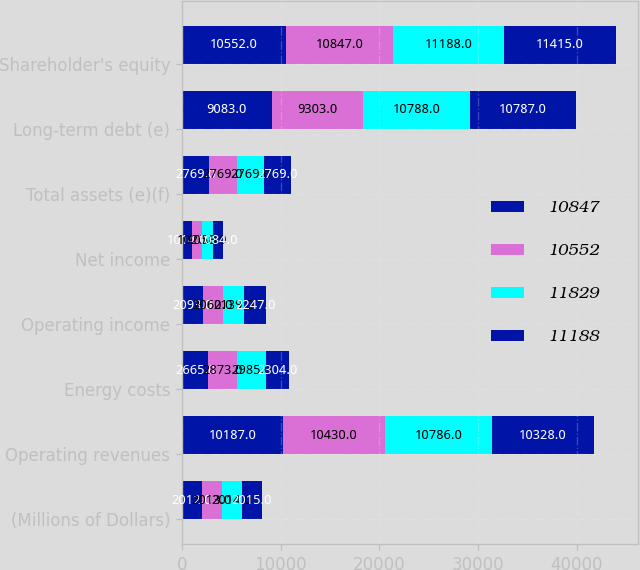<chart> <loc_0><loc_0><loc_500><loc_500><stacked_bar_chart><ecel><fcel>(Millions of Dollars)<fcel>Operating revenues<fcel>Energy costs<fcel>Operating income<fcel>Net income<fcel>Total assets (e)(f)<fcel>Long-term debt (e)<fcel>Shareholder's equity<nl><fcel>10847<fcel>2012<fcel>10187<fcel>2665<fcel>2093<fcel>1014<fcel>2769<fcel>9083<fcel>10552<nl><fcel>10552<fcel>2013<fcel>10430<fcel>2873<fcel>2060<fcel>1020<fcel>2769<fcel>9303<fcel>10847<nl><fcel>11829<fcel>2014<fcel>10786<fcel>2985<fcel>2139<fcel>1058<fcel>2769<fcel>10788<fcel>11188<nl><fcel>11188<fcel>2015<fcel>10328<fcel>2304<fcel>2247<fcel>1084<fcel>2769<fcel>10787<fcel>11415<nl></chart> 